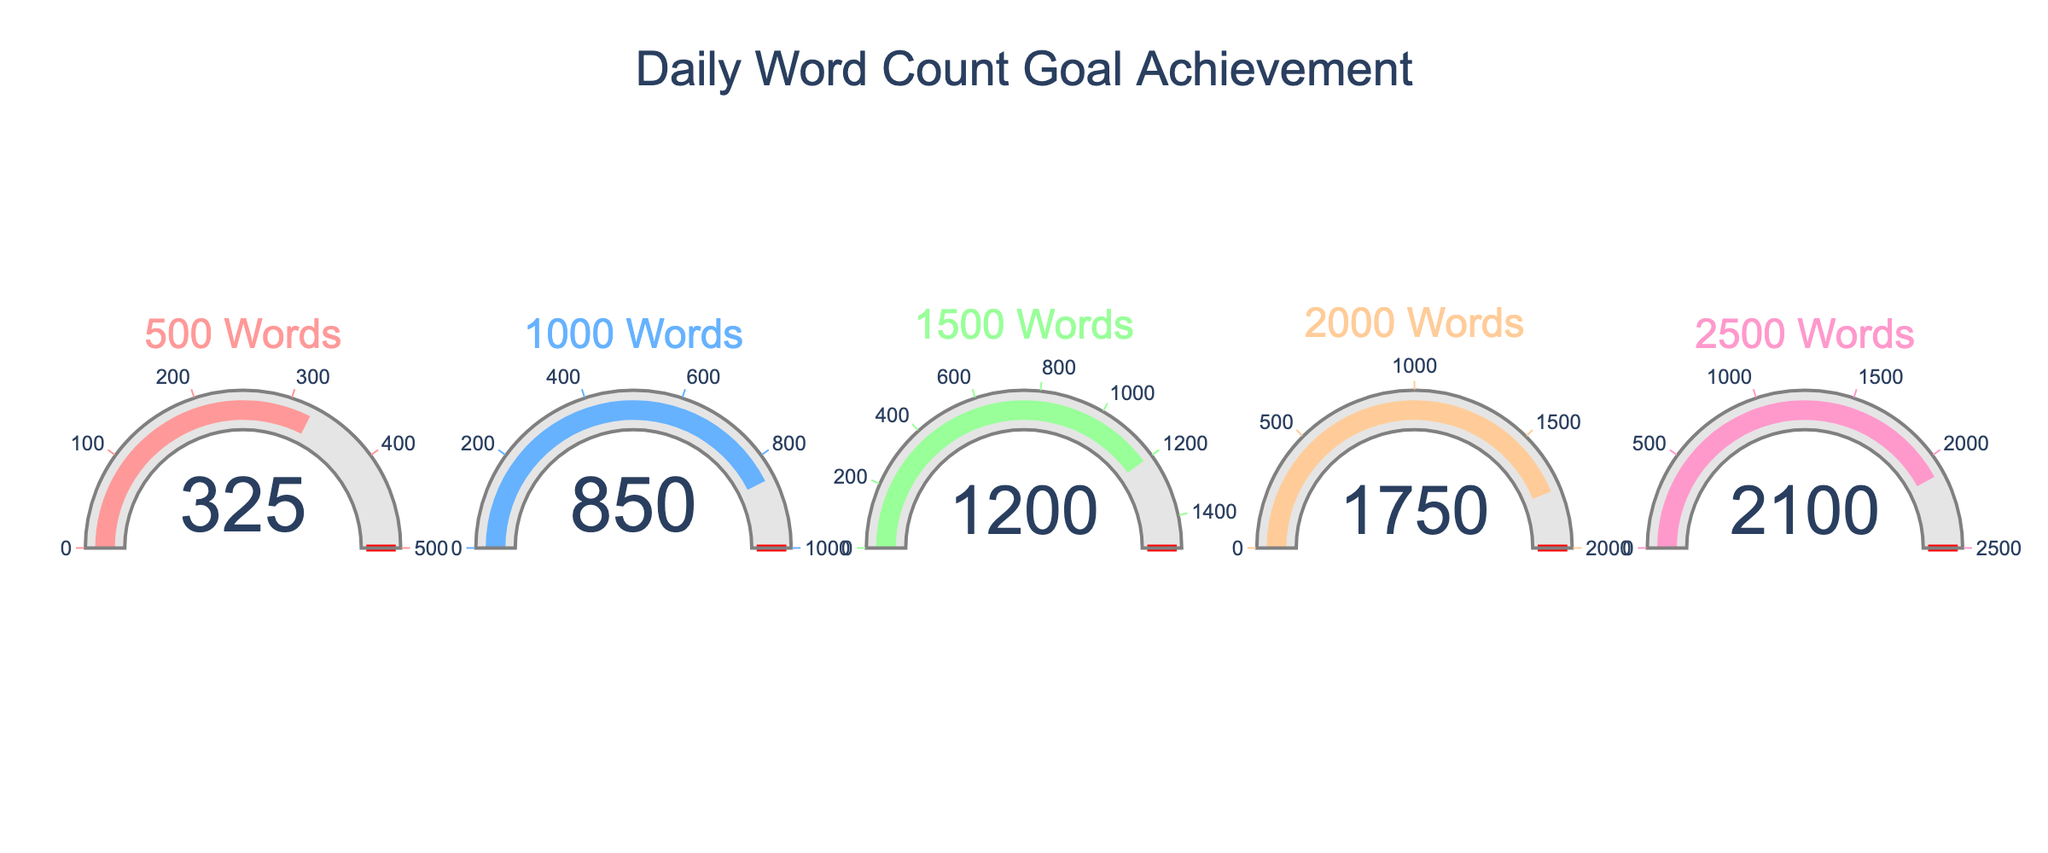Which daily goal has the highest achieved word count? By inspecting the gauges, the daily goal of 2500 words has the highest achieved word count, which is 2100.
Answer: 2500 words What is the title of the figure? The title is prominently displayed at the top of the figure.
Answer: Daily Word Count Goal Achievement How many daily goals are shown in the figure? Observing the number of gauges representing different daily goals reveals that there are 5 goals.
Answer: 5 Are the achieved word counts for all goals below the respective targets? Checking each gauge shows that all achieved counts (325, 850, 1200, 1750, and 2100) are below their respective targets (500, 1000, 1500, 2000, and 2500).
Answer: Yes What is the color of the gauge for the daily goal of 1500 words? By looking at the figure, the color associated with the 1500-word goal gauge is green.
Answer: Green Which daily goal has the closest achieved word count to its target? The gauge for the 2500-word goal shows an achieved count of 2100, which is the closest to its target compared to others when calculating differences (400 for 500, 150 for 1000, 300 for 1500, 250 for 2000, and 400 for 2500).
Answer: 1000 words What is the sum of the achieved word counts for all daily goals? Adding the achieved counts: 325 + 850 + 1200 + 1750 + 2100 = 6225.
Answer: 6225 Which color represents the gauge with the lowest achieved word count? Observing the gauges shows that the color pink represents the gauge with the lowest achieved word count (325 for the 500-word goal).
Answer: Pink 